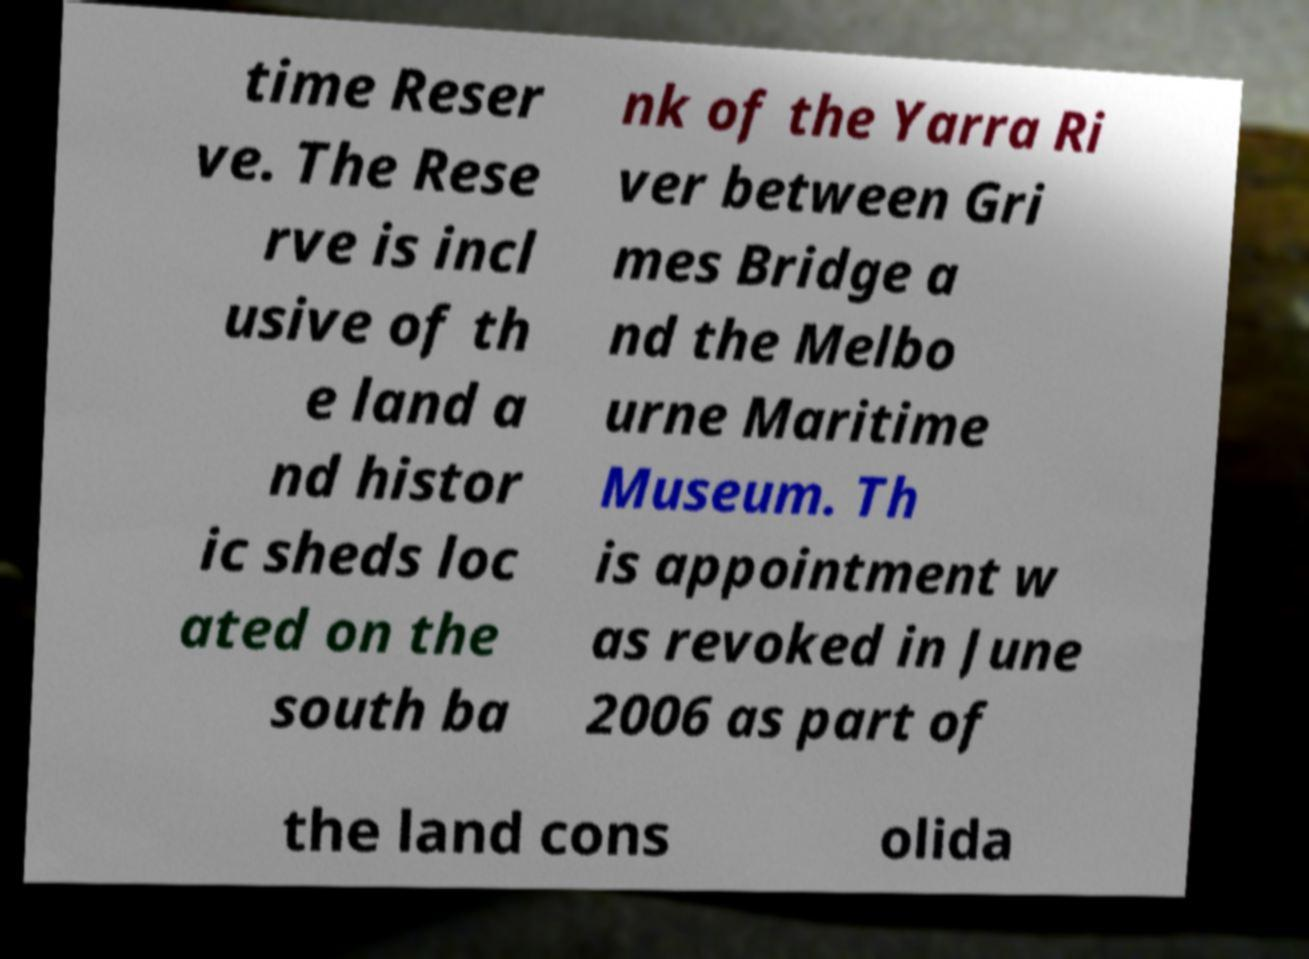Please identify and transcribe the text found in this image. time Reser ve. The Rese rve is incl usive of th e land a nd histor ic sheds loc ated on the south ba nk of the Yarra Ri ver between Gri mes Bridge a nd the Melbo urne Maritime Museum. Th is appointment w as revoked in June 2006 as part of the land cons olida 